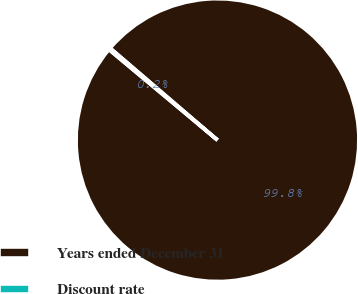<chart> <loc_0><loc_0><loc_500><loc_500><pie_chart><fcel>Years ended December 31<fcel>Discount rate<nl><fcel>99.79%<fcel>0.21%<nl></chart> 